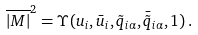<formula> <loc_0><loc_0><loc_500><loc_500>\overline { | M | } ^ { 2 } = \Upsilon ( u _ { i } , \bar { u } _ { i } , \tilde { q } _ { i \alpha } , \bar { \tilde { q } } _ { i \alpha } , 1 ) \, .</formula> 